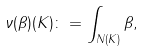Convert formula to latex. <formula><loc_0><loc_0><loc_500><loc_500>\nu ( \beta ) ( K ) \colon = \int _ { N ( K ) } \beta ,</formula> 